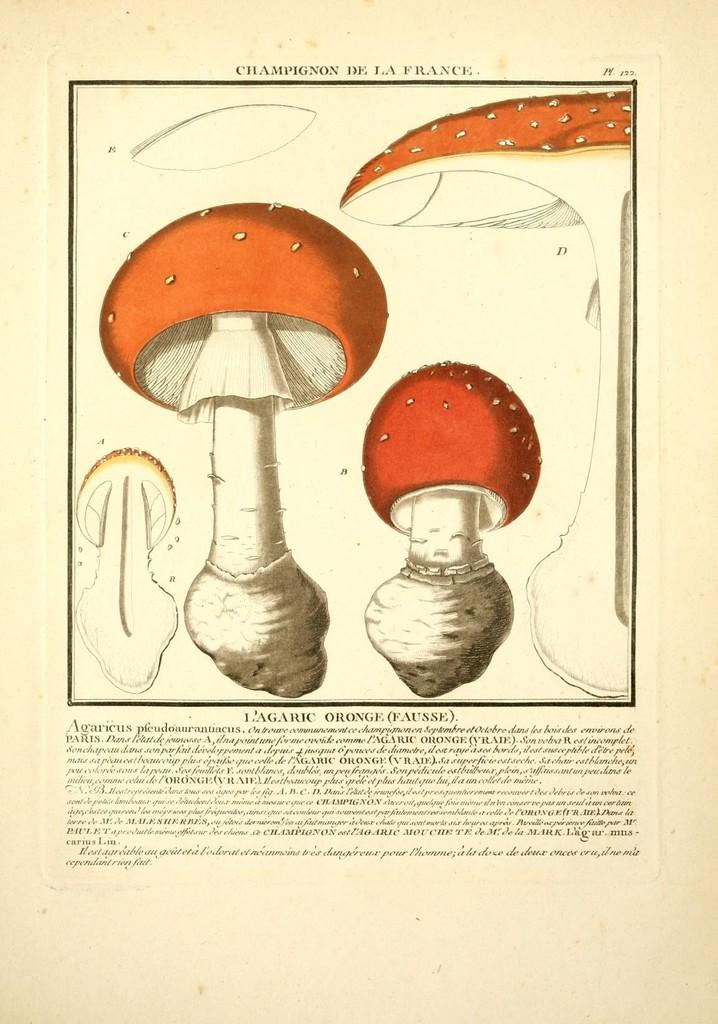What is depicted in the sketch in the image? There is a sketch of mushrooms in the image. What else can be seen on the image besides the sketch? There is writing on the image. What type of silk is being produced by the mushrooms in the image? There is no silk or mushroom production depicted in the image; it features a sketch of mushrooms and writing. 